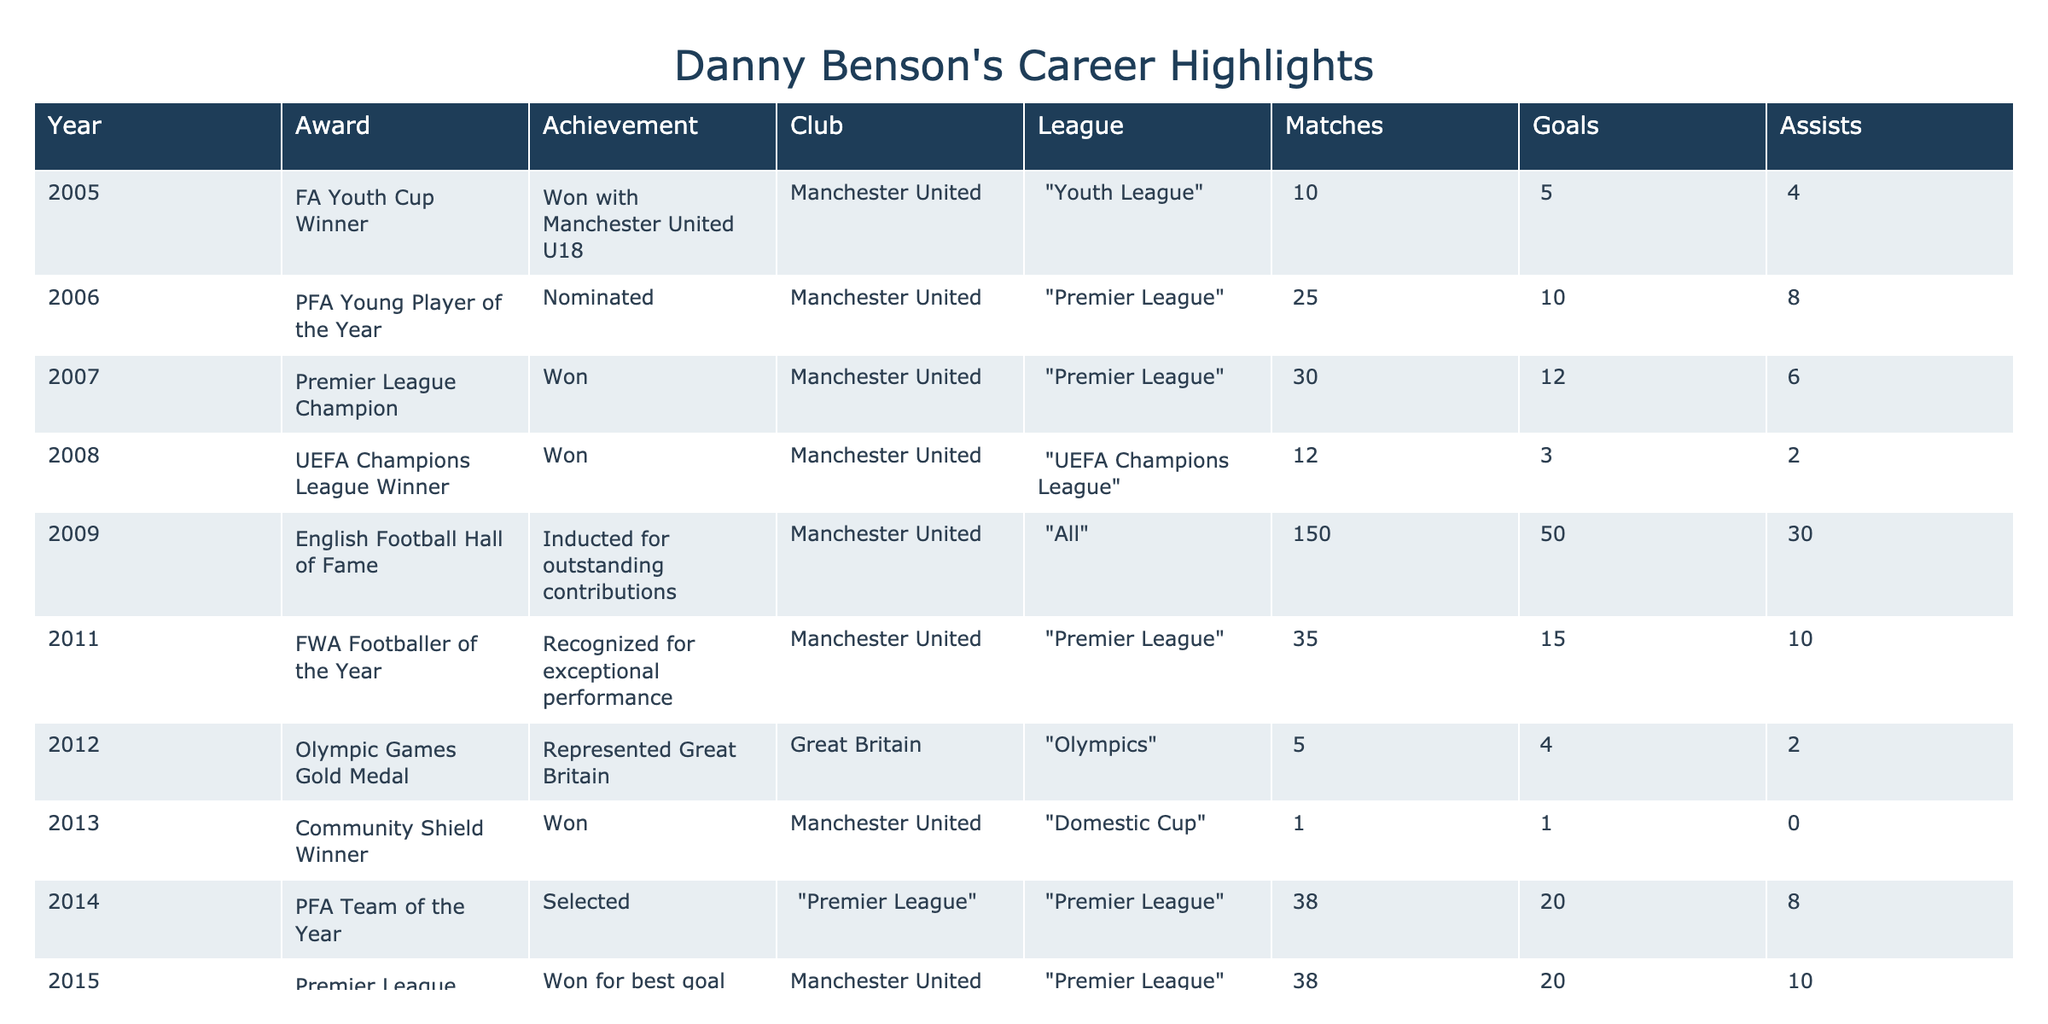What year did Danny Benson win the UEFA Champions League? The table shows that Danny Benson won the UEFA Champions League in 2008.
Answer: 2008 How many goals did Danny Benson score in his final season before retirement? In 2016, which is the year he announced his retirement, the table mentions that there are no matches or goals recorded.
Answer: 0 Which award did Danny Benson receive in 2011? According to the table, Danny Benson was recognized as the FWA Footballer of the Year in 2011.
Answer: FWA Footballer of the Year What was the total number of matches played by Danny Benson from 2005 to 2015? To find this, add the matches from all relevant years: 10 + 25 + 30 + 12 + 150 + 35 + 5 + 1 + 38 + 38 = 349 matches.
Answer: 349 Did Danny Benson ever play for a non-Premier League club? The table shows that all mentioned clubs where Danny played are under the Premier League or Manchester United, indicating he did not play for a non-Premier League club during these recorded years.
Answer: No How many assists did Danny Benson make in his career when considering only the years he won awards? The years with awards are 2005, 2006, 2007, 2008, 2009, 2011, 2012, 2013, 2014, and 2015. Adding assists in these years gives: 4 + 8 + 6 + 2 + 30 + 10 + 2 + 0 + 8 + 10 = 80 assists.
Answer: 80 What percentage of matches did Danny Benson score goals in during his career? First, calculate the total goals from 2005 to 2015 which are 5 + 10 + 12 + 3 + 50 + 15 + 4 + 1 + 20 + 20 = 150 goals. Next, use the total matches played which is 349 as calculated before. The percentage is (150/349) * 100 = approximately 42.94%.
Answer: 42.94% In how many years did Danny Benson win an award? From the table, Danny Benson received an award in 2005, 2007, 2008, 2009, 2011, 2012, 2013, 2014, 2015. This totals to 9 years of awards.
Answer: 9 